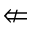<formula> <loc_0><loc_0><loc_500><loc_500>\ n L e f t a r r o w</formula> 